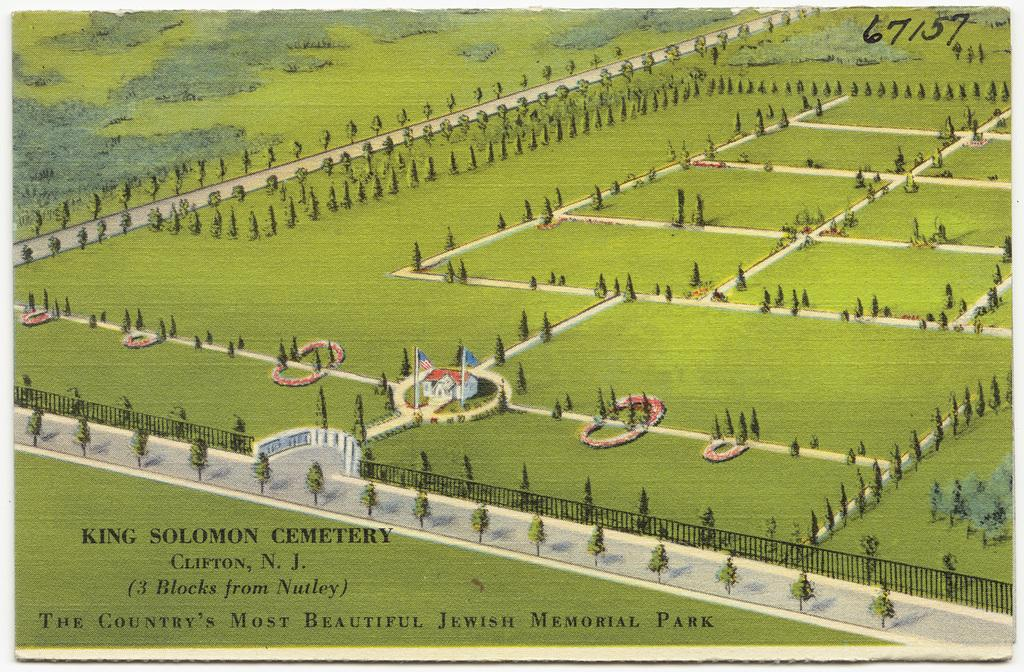<image>
Provide a brief description of the given image. A drawing of King Solomon Cemetery in Clifton, New Jersey. 